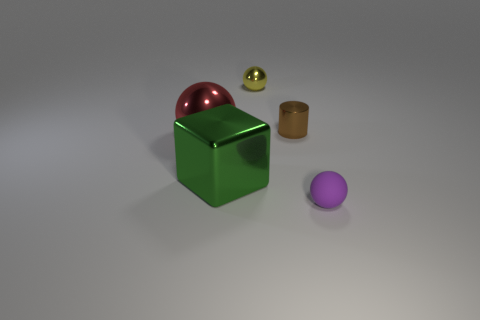Is there any other thing that is made of the same material as the purple ball?
Provide a succinct answer. No. What is the shape of the metal object that is left of the large green metal object?
Make the answer very short. Sphere. How many small blue things are there?
Your answer should be compact. 0. Is the material of the tiny purple object the same as the yellow thing?
Your response must be concise. No. Is the number of tiny purple rubber balls in front of the yellow object greater than the number of large cyan metallic spheres?
Your response must be concise. Yes. How many objects are tiny metallic cubes or small balls that are behind the purple rubber sphere?
Give a very brief answer. 1. Are there more cylinders that are behind the large red object than small purple objects left of the metal cylinder?
Provide a succinct answer. Yes. There is a tiny ball that is on the left side of the small shiny object on the right side of the sphere that is behind the small brown cylinder; what is it made of?
Give a very brief answer. Metal. The green object that is the same material as the brown thing is what shape?
Offer a very short reply. Cube. There is a metal object to the left of the large green metallic block; are there any spheres behind it?
Offer a terse response. Yes. 